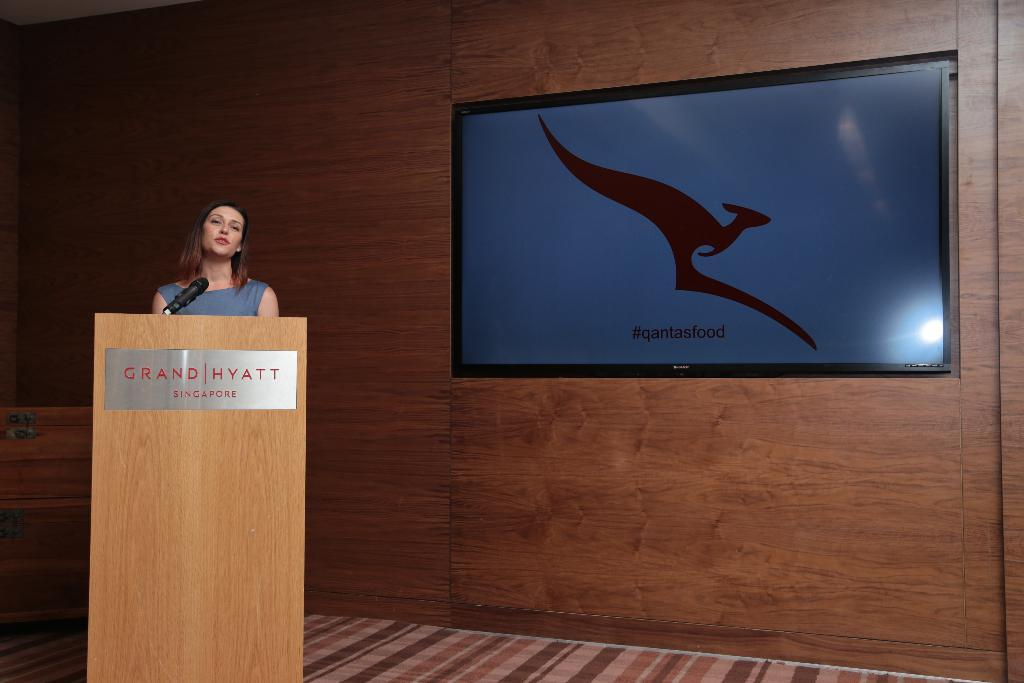Who is the main subject in the image? There is a woman in the image. What is the woman doing in the image? The woman is standing behind a speech desk. What object is beside the woman? There is a microphone beside the woman. What can be seen on the right side of the image? There is a screen on the right side of the image. How is the screen positioned in the image? The screen is placed on a wooden wall. What time of day is it in the image, and what is the woman's reaction to the news of a copper mine's closure? The time of day cannot be determined from the image, and there is no information about a copper mine or its closure in the image. 